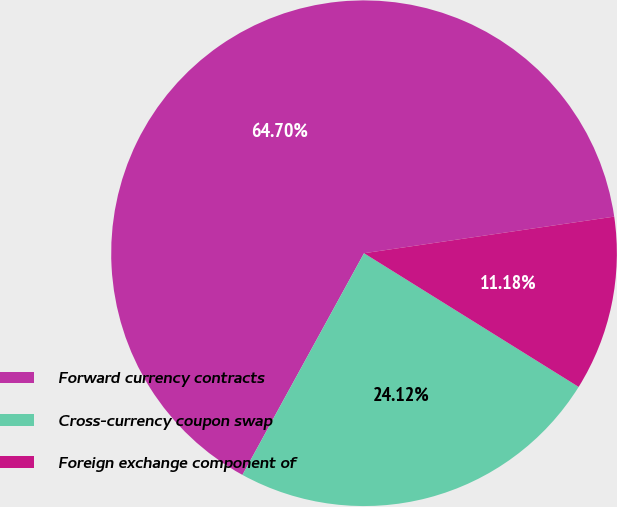<chart> <loc_0><loc_0><loc_500><loc_500><pie_chart><fcel>Forward currency contracts<fcel>Cross-currency coupon swap<fcel>Foreign exchange component of<nl><fcel>64.71%<fcel>24.12%<fcel>11.18%<nl></chart> 